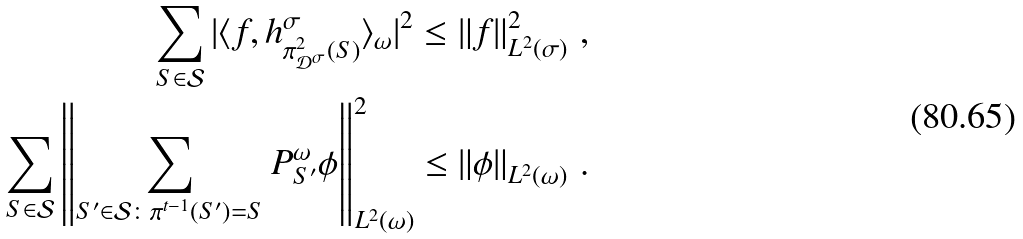Convert formula to latex. <formula><loc_0><loc_0><loc_500><loc_500>\sum _ { S \in \mathcal { S } } | \langle f , h _ { \pi _ { \mathcal { D } ^ { \sigma } } ^ { 2 } ( S ) } ^ { \sigma } \rangle _ { \omega } | ^ { 2 } \leq \left \| f \right \| _ { L ^ { 2 } ( \sigma ) } ^ { 2 } \, , \\ \sum _ { S \in \mathcal { S } } \left \| \sum _ { S ^ { \prime } \in \mathcal { S } \colon \pi ^ { t - 1 } ( S ^ { \prime } ) = S } P _ { S ^ { \prime } } ^ { \omega } \phi \right \| _ { L ^ { 2 } ( \omega ) } ^ { 2 } \leq \left \| \phi \right \| _ { L ^ { 2 } ( \omega ) } \, .</formula> 